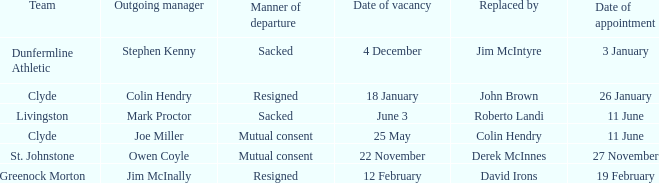Tell me the manner of departure for 3 january date of appointment Sacked. I'm looking to parse the entire table for insights. Could you assist me with that? {'header': ['Team', 'Outgoing manager', 'Manner of departure', 'Date of vacancy', 'Replaced by', 'Date of appointment'], 'rows': [['Dunfermline Athletic', 'Stephen Kenny', 'Sacked', '4 December', 'Jim McIntyre', '3 January'], ['Clyde', 'Colin Hendry', 'Resigned', '18 January', 'John Brown', '26 January'], ['Livingston', 'Mark Proctor', 'Sacked', 'June 3', 'Roberto Landi', '11 June'], ['Clyde', 'Joe Miller', 'Mutual consent', '25 May', 'Colin Hendry', '11 June'], ['St. Johnstone', 'Owen Coyle', 'Mutual consent', '22 November', 'Derek McInnes', '27 November'], ['Greenock Morton', 'Jim McInally', 'Resigned', '12 February', 'David Irons', '19 February']]} 